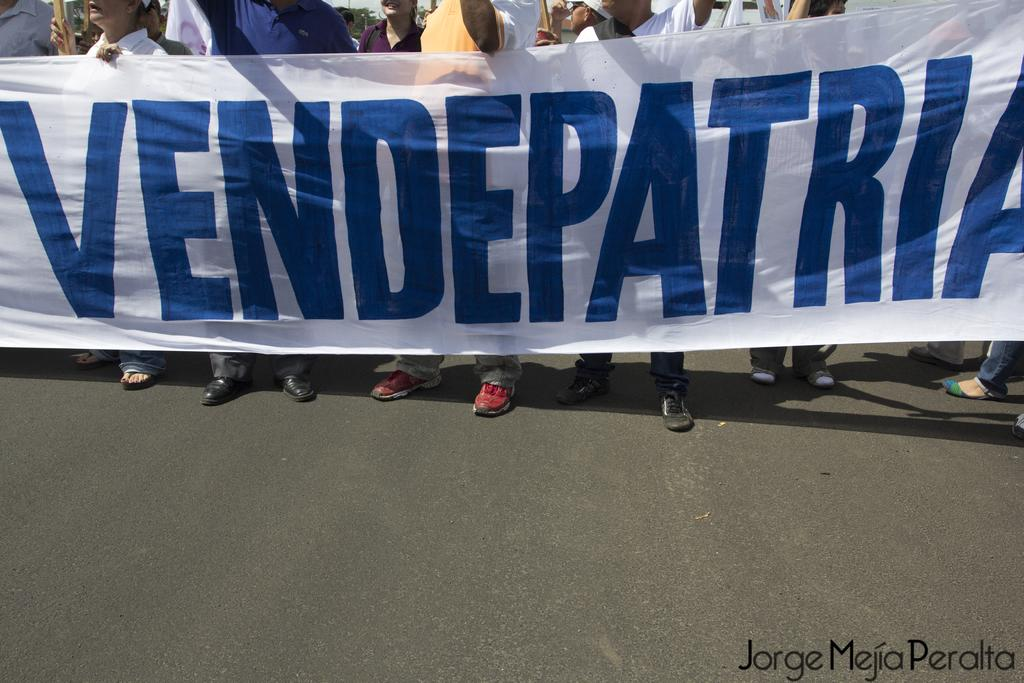What is the main subject of the image? The main subject of the image is a group of men. Where are the men located in the image? The men are standing on the road in the image. What are the men holding in their hands? The men are holding a white cloth banner in their hands. What type of balls are being juggled by the men in the image? There are no balls present in the image; the men are holding a white cloth banner. Can you describe the insects flying around the men in the image? There are no insects present in the image; the men are holding a white cloth banner. 